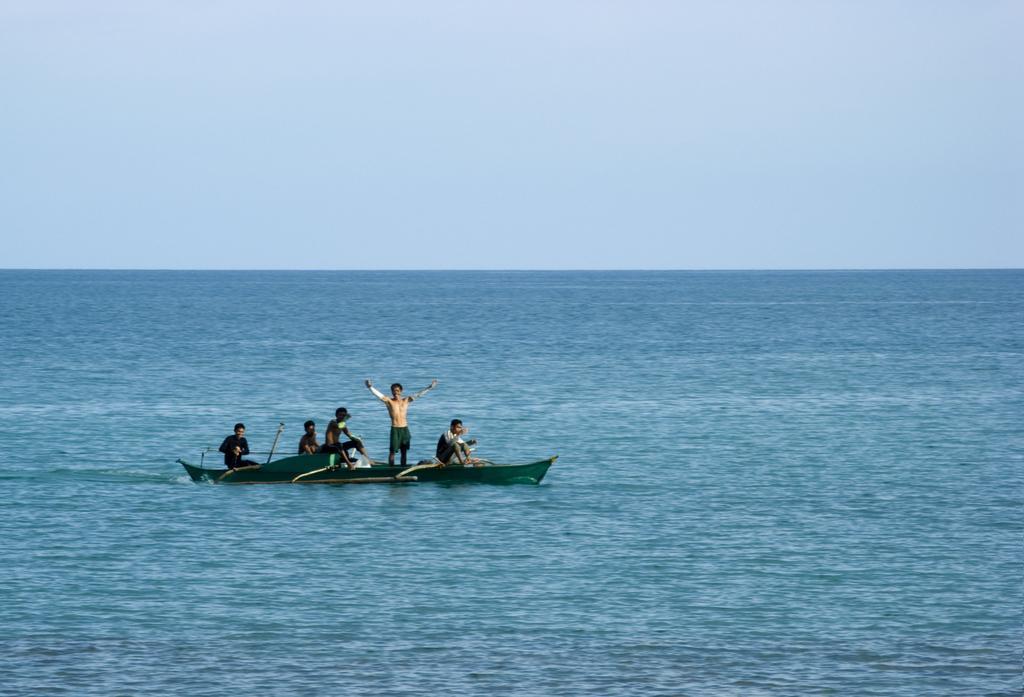Can you describe this image briefly? In this image we can see a boat on the water. On the boat there are few people. In the background there is sky. 